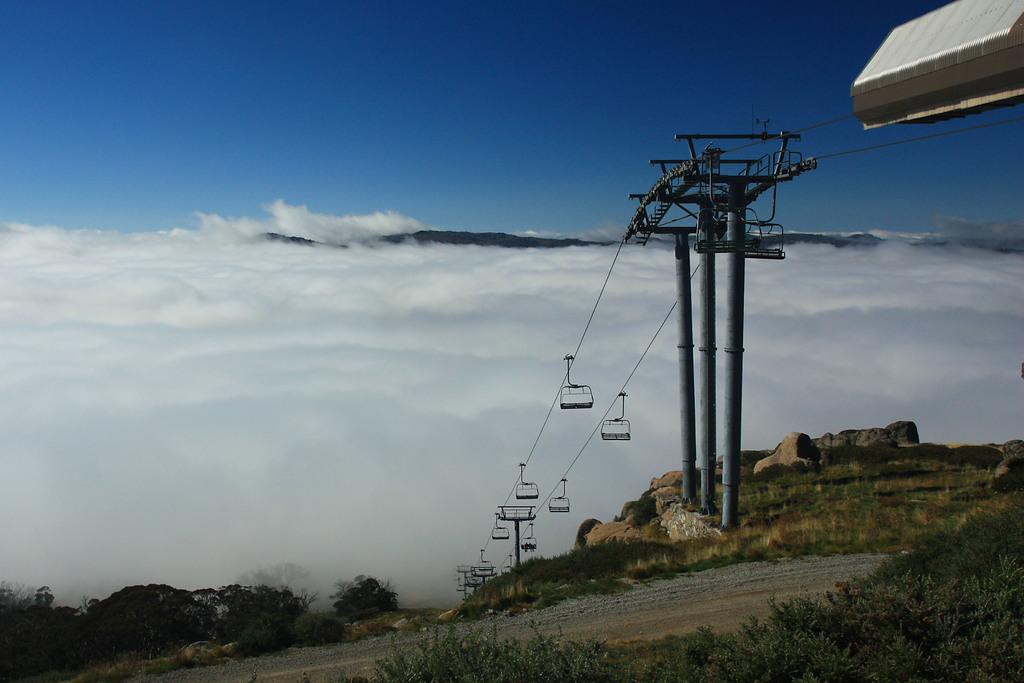What type of transportation is shown in the image? There is a ropeway in the image. How is the ropeway supported? The ropeway is connected to poles. What type of geographical feature is visible in the image? There is a stone mountain in the image. What type of vegetation is present in the image? Trees are present in the image. What is visible in the sky in the image? Clouds are visible in the sky. What type of grain is being harvested in the image? There is no grain or harvesting activity present in the image. 